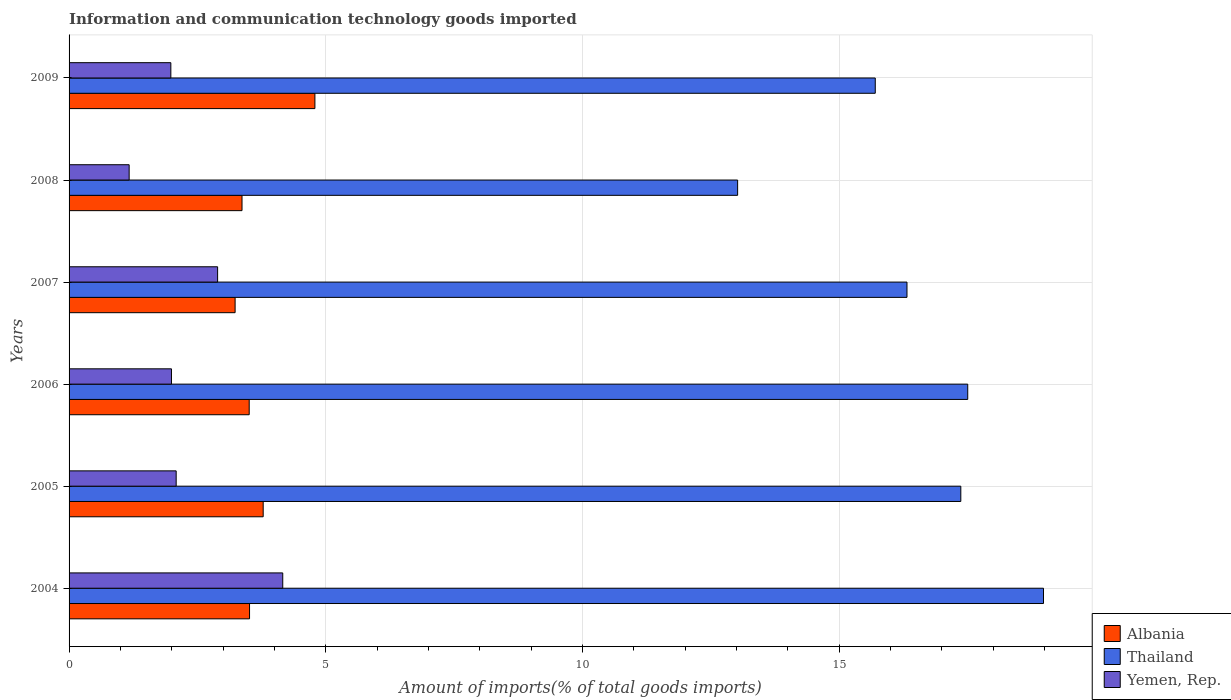How many groups of bars are there?
Provide a succinct answer. 6. Are the number of bars on each tick of the Y-axis equal?
Provide a short and direct response. Yes. How many bars are there on the 5th tick from the top?
Offer a very short reply. 3. How many bars are there on the 5th tick from the bottom?
Your answer should be compact. 3. What is the amount of goods imported in Albania in 2004?
Keep it short and to the point. 3.52. Across all years, what is the maximum amount of goods imported in Albania?
Ensure brevity in your answer.  4.79. Across all years, what is the minimum amount of goods imported in Thailand?
Provide a short and direct response. 13.02. In which year was the amount of goods imported in Yemen, Rep. minimum?
Your answer should be compact. 2008. What is the total amount of goods imported in Thailand in the graph?
Keep it short and to the point. 98.91. What is the difference between the amount of goods imported in Albania in 2004 and that in 2008?
Make the answer very short. 0.15. What is the difference between the amount of goods imported in Thailand in 2009 and the amount of goods imported in Yemen, Rep. in 2007?
Keep it short and to the point. 12.81. What is the average amount of goods imported in Yemen, Rep. per year?
Your response must be concise. 2.38. In the year 2007, what is the difference between the amount of goods imported in Albania and amount of goods imported in Thailand?
Your answer should be very brief. -13.09. In how many years, is the amount of goods imported in Thailand greater than 18 %?
Keep it short and to the point. 1. What is the ratio of the amount of goods imported in Albania in 2008 to that in 2009?
Give a very brief answer. 0.7. What is the difference between the highest and the second highest amount of goods imported in Thailand?
Offer a very short reply. 1.48. What is the difference between the highest and the lowest amount of goods imported in Thailand?
Offer a very short reply. 5.96. In how many years, is the amount of goods imported in Thailand greater than the average amount of goods imported in Thailand taken over all years?
Offer a terse response. 3. Is the sum of the amount of goods imported in Yemen, Rep. in 2005 and 2009 greater than the maximum amount of goods imported in Thailand across all years?
Your answer should be very brief. No. What does the 1st bar from the top in 2007 represents?
Your answer should be very brief. Yemen, Rep. What does the 2nd bar from the bottom in 2004 represents?
Provide a short and direct response. Thailand. How many bars are there?
Give a very brief answer. 18. How many years are there in the graph?
Offer a very short reply. 6. Where does the legend appear in the graph?
Make the answer very short. Bottom right. How are the legend labels stacked?
Offer a very short reply. Vertical. What is the title of the graph?
Give a very brief answer. Information and communication technology goods imported. Does "Caribbean small states" appear as one of the legend labels in the graph?
Offer a terse response. No. What is the label or title of the X-axis?
Keep it short and to the point. Amount of imports(% of total goods imports). What is the label or title of the Y-axis?
Your answer should be very brief. Years. What is the Amount of imports(% of total goods imports) of Albania in 2004?
Make the answer very short. 3.52. What is the Amount of imports(% of total goods imports) of Thailand in 2004?
Offer a very short reply. 18.98. What is the Amount of imports(% of total goods imports) in Yemen, Rep. in 2004?
Your response must be concise. 4.16. What is the Amount of imports(% of total goods imports) in Albania in 2005?
Offer a terse response. 3.78. What is the Amount of imports(% of total goods imports) of Thailand in 2005?
Offer a very short reply. 17.37. What is the Amount of imports(% of total goods imports) of Yemen, Rep. in 2005?
Ensure brevity in your answer.  2.09. What is the Amount of imports(% of total goods imports) in Albania in 2006?
Ensure brevity in your answer.  3.51. What is the Amount of imports(% of total goods imports) in Thailand in 2006?
Give a very brief answer. 17.51. What is the Amount of imports(% of total goods imports) of Yemen, Rep. in 2006?
Your answer should be very brief. 1.99. What is the Amount of imports(% of total goods imports) in Albania in 2007?
Your response must be concise. 3.23. What is the Amount of imports(% of total goods imports) of Thailand in 2007?
Offer a terse response. 16.32. What is the Amount of imports(% of total goods imports) in Yemen, Rep. in 2007?
Give a very brief answer. 2.89. What is the Amount of imports(% of total goods imports) of Albania in 2008?
Ensure brevity in your answer.  3.37. What is the Amount of imports(% of total goods imports) in Thailand in 2008?
Keep it short and to the point. 13.02. What is the Amount of imports(% of total goods imports) of Yemen, Rep. in 2008?
Your answer should be very brief. 1.17. What is the Amount of imports(% of total goods imports) in Albania in 2009?
Provide a succinct answer. 4.79. What is the Amount of imports(% of total goods imports) of Thailand in 2009?
Offer a very short reply. 15.7. What is the Amount of imports(% of total goods imports) of Yemen, Rep. in 2009?
Offer a very short reply. 1.98. Across all years, what is the maximum Amount of imports(% of total goods imports) in Albania?
Your answer should be compact. 4.79. Across all years, what is the maximum Amount of imports(% of total goods imports) in Thailand?
Ensure brevity in your answer.  18.98. Across all years, what is the maximum Amount of imports(% of total goods imports) in Yemen, Rep.?
Make the answer very short. 4.16. Across all years, what is the minimum Amount of imports(% of total goods imports) in Albania?
Offer a terse response. 3.23. Across all years, what is the minimum Amount of imports(% of total goods imports) of Thailand?
Ensure brevity in your answer.  13.02. Across all years, what is the minimum Amount of imports(% of total goods imports) in Yemen, Rep.?
Make the answer very short. 1.17. What is the total Amount of imports(% of total goods imports) of Albania in the graph?
Make the answer very short. 22.2. What is the total Amount of imports(% of total goods imports) of Thailand in the graph?
Your response must be concise. 98.91. What is the total Amount of imports(% of total goods imports) in Yemen, Rep. in the graph?
Offer a very short reply. 14.29. What is the difference between the Amount of imports(% of total goods imports) of Albania in 2004 and that in 2005?
Ensure brevity in your answer.  -0.27. What is the difference between the Amount of imports(% of total goods imports) in Thailand in 2004 and that in 2005?
Ensure brevity in your answer.  1.61. What is the difference between the Amount of imports(% of total goods imports) in Yemen, Rep. in 2004 and that in 2005?
Give a very brief answer. 2.08. What is the difference between the Amount of imports(% of total goods imports) in Albania in 2004 and that in 2006?
Ensure brevity in your answer.  0.01. What is the difference between the Amount of imports(% of total goods imports) of Thailand in 2004 and that in 2006?
Provide a short and direct response. 1.48. What is the difference between the Amount of imports(% of total goods imports) in Yemen, Rep. in 2004 and that in 2006?
Your answer should be very brief. 2.17. What is the difference between the Amount of imports(% of total goods imports) in Albania in 2004 and that in 2007?
Make the answer very short. 0.28. What is the difference between the Amount of imports(% of total goods imports) in Thailand in 2004 and that in 2007?
Ensure brevity in your answer.  2.66. What is the difference between the Amount of imports(% of total goods imports) in Yemen, Rep. in 2004 and that in 2007?
Provide a short and direct response. 1.27. What is the difference between the Amount of imports(% of total goods imports) in Albania in 2004 and that in 2008?
Provide a short and direct response. 0.15. What is the difference between the Amount of imports(% of total goods imports) of Thailand in 2004 and that in 2008?
Your answer should be very brief. 5.96. What is the difference between the Amount of imports(% of total goods imports) of Yemen, Rep. in 2004 and that in 2008?
Provide a short and direct response. 2.99. What is the difference between the Amount of imports(% of total goods imports) of Albania in 2004 and that in 2009?
Ensure brevity in your answer.  -1.27. What is the difference between the Amount of imports(% of total goods imports) in Thailand in 2004 and that in 2009?
Your answer should be very brief. 3.28. What is the difference between the Amount of imports(% of total goods imports) of Yemen, Rep. in 2004 and that in 2009?
Your answer should be compact. 2.18. What is the difference between the Amount of imports(% of total goods imports) of Albania in 2005 and that in 2006?
Offer a very short reply. 0.27. What is the difference between the Amount of imports(% of total goods imports) of Thailand in 2005 and that in 2006?
Offer a very short reply. -0.13. What is the difference between the Amount of imports(% of total goods imports) in Yemen, Rep. in 2005 and that in 2006?
Provide a succinct answer. 0.09. What is the difference between the Amount of imports(% of total goods imports) in Albania in 2005 and that in 2007?
Ensure brevity in your answer.  0.55. What is the difference between the Amount of imports(% of total goods imports) in Thailand in 2005 and that in 2007?
Provide a short and direct response. 1.05. What is the difference between the Amount of imports(% of total goods imports) in Yemen, Rep. in 2005 and that in 2007?
Ensure brevity in your answer.  -0.81. What is the difference between the Amount of imports(% of total goods imports) of Albania in 2005 and that in 2008?
Provide a succinct answer. 0.41. What is the difference between the Amount of imports(% of total goods imports) in Thailand in 2005 and that in 2008?
Give a very brief answer. 4.35. What is the difference between the Amount of imports(% of total goods imports) in Yemen, Rep. in 2005 and that in 2008?
Your response must be concise. 0.92. What is the difference between the Amount of imports(% of total goods imports) in Albania in 2005 and that in 2009?
Give a very brief answer. -1.01. What is the difference between the Amount of imports(% of total goods imports) in Thailand in 2005 and that in 2009?
Make the answer very short. 1.67. What is the difference between the Amount of imports(% of total goods imports) in Yemen, Rep. in 2005 and that in 2009?
Your answer should be compact. 0.1. What is the difference between the Amount of imports(% of total goods imports) in Albania in 2006 and that in 2007?
Keep it short and to the point. 0.27. What is the difference between the Amount of imports(% of total goods imports) of Thailand in 2006 and that in 2007?
Your answer should be compact. 1.18. What is the difference between the Amount of imports(% of total goods imports) of Yemen, Rep. in 2006 and that in 2007?
Keep it short and to the point. -0.9. What is the difference between the Amount of imports(% of total goods imports) of Albania in 2006 and that in 2008?
Provide a succinct answer. 0.14. What is the difference between the Amount of imports(% of total goods imports) of Thailand in 2006 and that in 2008?
Ensure brevity in your answer.  4.48. What is the difference between the Amount of imports(% of total goods imports) of Yemen, Rep. in 2006 and that in 2008?
Offer a terse response. 0.82. What is the difference between the Amount of imports(% of total goods imports) in Albania in 2006 and that in 2009?
Provide a short and direct response. -1.28. What is the difference between the Amount of imports(% of total goods imports) of Thailand in 2006 and that in 2009?
Provide a short and direct response. 1.8. What is the difference between the Amount of imports(% of total goods imports) in Yemen, Rep. in 2006 and that in 2009?
Give a very brief answer. 0.01. What is the difference between the Amount of imports(% of total goods imports) in Albania in 2007 and that in 2008?
Your answer should be compact. -0.13. What is the difference between the Amount of imports(% of total goods imports) of Thailand in 2007 and that in 2008?
Keep it short and to the point. 3.3. What is the difference between the Amount of imports(% of total goods imports) of Yemen, Rep. in 2007 and that in 2008?
Give a very brief answer. 1.72. What is the difference between the Amount of imports(% of total goods imports) in Albania in 2007 and that in 2009?
Offer a terse response. -1.55. What is the difference between the Amount of imports(% of total goods imports) in Thailand in 2007 and that in 2009?
Provide a succinct answer. 0.62. What is the difference between the Amount of imports(% of total goods imports) in Yemen, Rep. in 2007 and that in 2009?
Give a very brief answer. 0.91. What is the difference between the Amount of imports(% of total goods imports) in Albania in 2008 and that in 2009?
Your response must be concise. -1.42. What is the difference between the Amount of imports(% of total goods imports) of Thailand in 2008 and that in 2009?
Your answer should be very brief. -2.68. What is the difference between the Amount of imports(% of total goods imports) in Yemen, Rep. in 2008 and that in 2009?
Make the answer very short. -0.81. What is the difference between the Amount of imports(% of total goods imports) of Albania in 2004 and the Amount of imports(% of total goods imports) of Thailand in 2005?
Offer a very short reply. -13.86. What is the difference between the Amount of imports(% of total goods imports) in Albania in 2004 and the Amount of imports(% of total goods imports) in Yemen, Rep. in 2005?
Make the answer very short. 1.43. What is the difference between the Amount of imports(% of total goods imports) of Thailand in 2004 and the Amount of imports(% of total goods imports) of Yemen, Rep. in 2005?
Your response must be concise. 16.9. What is the difference between the Amount of imports(% of total goods imports) of Albania in 2004 and the Amount of imports(% of total goods imports) of Thailand in 2006?
Your answer should be very brief. -13.99. What is the difference between the Amount of imports(% of total goods imports) of Albania in 2004 and the Amount of imports(% of total goods imports) of Yemen, Rep. in 2006?
Provide a succinct answer. 1.52. What is the difference between the Amount of imports(% of total goods imports) of Thailand in 2004 and the Amount of imports(% of total goods imports) of Yemen, Rep. in 2006?
Keep it short and to the point. 16.99. What is the difference between the Amount of imports(% of total goods imports) in Albania in 2004 and the Amount of imports(% of total goods imports) in Thailand in 2007?
Your response must be concise. -12.81. What is the difference between the Amount of imports(% of total goods imports) of Albania in 2004 and the Amount of imports(% of total goods imports) of Yemen, Rep. in 2007?
Give a very brief answer. 0.62. What is the difference between the Amount of imports(% of total goods imports) of Thailand in 2004 and the Amount of imports(% of total goods imports) of Yemen, Rep. in 2007?
Provide a succinct answer. 16.09. What is the difference between the Amount of imports(% of total goods imports) of Albania in 2004 and the Amount of imports(% of total goods imports) of Thailand in 2008?
Give a very brief answer. -9.51. What is the difference between the Amount of imports(% of total goods imports) of Albania in 2004 and the Amount of imports(% of total goods imports) of Yemen, Rep. in 2008?
Provide a succinct answer. 2.35. What is the difference between the Amount of imports(% of total goods imports) of Thailand in 2004 and the Amount of imports(% of total goods imports) of Yemen, Rep. in 2008?
Make the answer very short. 17.81. What is the difference between the Amount of imports(% of total goods imports) in Albania in 2004 and the Amount of imports(% of total goods imports) in Thailand in 2009?
Ensure brevity in your answer.  -12.19. What is the difference between the Amount of imports(% of total goods imports) in Albania in 2004 and the Amount of imports(% of total goods imports) in Yemen, Rep. in 2009?
Provide a succinct answer. 1.53. What is the difference between the Amount of imports(% of total goods imports) of Thailand in 2004 and the Amount of imports(% of total goods imports) of Yemen, Rep. in 2009?
Ensure brevity in your answer.  17. What is the difference between the Amount of imports(% of total goods imports) of Albania in 2005 and the Amount of imports(% of total goods imports) of Thailand in 2006?
Ensure brevity in your answer.  -13.72. What is the difference between the Amount of imports(% of total goods imports) of Albania in 2005 and the Amount of imports(% of total goods imports) of Yemen, Rep. in 2006?
Offer a terse response. 1.79. What is the difference between the Amount of imports(% of total goods imports) in Thailand in 2005 and the Amount of imports(% of total goods imports) in Yemen, Rep. in 2006?
Your answer should be compact. 15.38. What is the difference between the Amount of imports(% of total goods imports) of Albania in 2005 and the Amount of imports(% of total goods imports) of Thailand in 2007?
Your answer should be very brief. -12.54. What is the difference between the Amount of imports(% of total goods imports) in Albania in 2005 and the Amount of imports(% of total goods imports) in Yemen, Rep. in 2007?
Offer a terse response. 0.89. What is the difference between the Amount of imports(% of total goods imports) of Thailand in 2005 and the Amount of imports(% of total goods imports) of Yemen, Rep. in 2007?
Make the answer very short. 14.48. What is the difference between the Amount of imports(% of total goods imports) in Albania in 2005 and the Amount of imports(% of total goods imports) in Thailand in 2008?
Your answer should be compact. -9.24. What is the difference between the Amount of imports(% of total goods imports) of Albania in 2005 and the Amount of imports(% of total goods imports) of Yemen, Rep. in 2008?
Keep it short and to the point. 2.61. What is the difference between the Amount of imports(% of total goods imports) of Thailand in 2005 and the Amount of imports(% of total goods imports) of Yemen, Rep. in 2008?
Your answer should be very brief. 16.2. What is the difference between the Amount of imports(% of total goods imports) of Albania in 2005 and the Amount of imports(% of total goods imports) of Thailand in 2009?
Your answer should be very brief. -11.92. What is the difference between the Amount of imports(% of total goods imports) of Albania in 2005 and the Amount of imports(% of total goods imports) of Yemen, Rep. in 2009?
Your response must be concise. 1.8. What is the difference between the Amount of imports(% of total goods imports) of Thailand in 2005 and the Amount of imports(% of total goods imports) of Yemen, Rep. in 2009?
Keep it short and to the point. 15.39. What is the difference between the Amount of imports(% of total goods imports) of Albania in 2006 and the Amount of imports(% of total goods imports) of Thailand in 2007?
Offer a very short reply. -12.81. What is the difference between the Amount of imports(% of total goods imports) in Albania in 2006 and the Amount of imports(% of total goods imports) in Yemen, Rep. in 2007?
Offer a terse response. 0.62. What is the difference between the Amount of imports(% of total goods imports) of Thailand in 2006 and the Amount of imports(% of total goods imports) of Yemen, Rep. in 2007?
Your answer should be very brief. 14.61. What is the difference between the Amount of imports(% of total goods imports) in Albania in 2006 and the Amount of imports(% of total goods imports) in Thailand in 2008?
Ensure brevity in your answer.  -9.51. What is the difference between the Amount of imports(% of total goods imports) in Albania in 2006 and the Amount of imports(% of total goods imports) in Yemen, Rep. in 2008?
Ensure brevity in your answer.  2.34. What is the difference between the Amount of imports(% of total goods imports) of Thailand in 2006 and the Amount of imports(% of total goods imports) of Yemen, Rep. in 2008?
Give a very brief answer. 16.34. What is the difference between the Amount of imports(% of total goods imports) of Albania in 2006 and the Amount of imports(% of total goods imports) of Thailand in 2009?
Provide a short and direct response. -12.2. What is the difference between the Amount of imports(% of total goods imports) in Albania in 2006 and the Amount of imports(% of total goods imports) in Yemen, Rep. in 2009?
Give a very brief answer. 1.53. What is the difference between the Amount of imports(% of total goods imports) in Thailand in 2006 and the Amount of imports(% of total goods imports) in Yemen, Rep. in 2009?
Offer a very short reply. 15.52. What is the difference between the Amount of imports(% of total goods imports) of Albania in 2007 and the Amount of imports(% of total goods imports) of Thailand in 2008?
Give a very brief answer. -9.79. What is the difference between the Amount of imports(% of total goods imports) in Albania in 2007 and the Amount of imports(% of total goods imports) in Yemen, Rep. in 2008?
Ensure brevity in your answer.  2.06. What is the difference between the Amount of imports(% of total goods imports) in Thailand in 2007 and the Amount of imports(% of total goods imports) in Yemen, Rep. in 2008?
Offer a very short reply. 15.15. What is the difference between the Amount of imports(% of total goods imports) of Albania in 2007 and the Amount of imports(% of total goods imports) of Thailand in 2009?
Your response must be concise. -12.47. What is the difference between the Amount of imports(% of total goods imports) in Albania in 2007 and the Amount of imports(% of total goods imports) in Yemen, Rep. in 2009?
Ensure brevity in your answer.  1.25. What is the difference between the Amount of imports(% of total goods imports) of Thailand in 2007 and the Amount of imports(% of total goods imports) of Yemen, Rep. in 2009?
Your response must be concise. 14.34. What is the difference between the Amount of imports(% of total goods imports) in Albania in 2008 and the Amount of imports(% of total goods imports) in Thailand in 2009?
Make the answer very short. -12.34. What is the difference between the Amount of imports(% of total goods imports) in Albania in 2008 and the Amount of imports(% of total goods imports) in Yemen, Rep. in 2009?
Make the answer very short. 1.39. What is the difference between the Amount of imports(% of total goods imports) in Thailand in 2008 and the Amount of imports(% of total goods imports) in Yemen, Rep. in 2009?
Your answer should be compact. 11.04. What is the average Amount of imports(% of total goods imports) of Albania per year?
Your answer should be very brief. 3.7. What is the average Amount of imports(% of total goods imports) in Thailand per year?
Your response must be concise. 16.48. What is the average Amount of imports(% of total goods imports) of Yemen, Rep. per year?
Offer a terse response. 2.38. In the year 2004, what is the difference between the Amount of imports(% of total goods imports) of Albania and Amount of imports(% of total goods imports) of Thailand?
Keep it short and to the point. -15.47. In the year 2004, what is the difference between the Amount of imports(% of total goods imports) of Albania and Amount of imports(% of total goods imports) of Yemen, Rep.?
Your answer should be very brief. -0.65. In the year 2004, what is the difference between the Amount of imports(% of total goods imports) in Thailand and Amount of imports(% of total goods imports) in Yemen, Rep.?
Offer a terse response. 14.82. In the year 2005, what is the difference between the Amount of imports(% of total goods imports) in Albania and Amount of imports(% of total goods imports) in Thailand?
Offer a terse response. -13.59. In the year 2005, what is the difference between the Amount of imports(% of total goods imports) of Albania and Amount of imports(% of total goods imports) of Yemen, Rep.?
Make the answer very short. 1.7. In the year 2005, what is the difference between the Amount of imports(% of total goods imports) of Thailand and Amount of imports(% of total goods imports) of Yemen, Rep.?
Your answer should be very brief. 15.28. In the year 2006, what is the difference between the Amount of imports(% of total goods imports) in Albania and Amount of imports(% of total goods imports) in Thailand?
Offer a very short reply. -14. In the year 2006, what is the difference between the Amount of imports(% of total goods imports) in Albania and Amount of imports(% of total goods imports) in Yemen, Rep.?
Your answer should be compact. 1.51. In the year 2006, what is the difference between the Amount of imports(% of total goods imports) in Thailand and Amount of imports(% of total goods imports) in Yemen, Rep.?
Ensure brevity in your answer.  15.51. In the year 2007, what is the difference between the Amount of imports(% of total goods imports) of Albania and Amount of imports(% of total goods imports) of Thailand?
Offer a very short reply. -13.09. In the year 2007, what is the difference between the Amount of imports(% of total goods imports) in Albania and Amount of imports(% of total goods imports) in Yemen, Rep.?
Ensure brevity in your answer.  0.34. In the year 2007, what is the difference between the Amount of imports(% of total goods imports) in Thailand and Amount of imports(% of total goods imports) in Yemen, Rep.?
Offer a very short reply. 13.43. In the year 2008, what is the difference between the Amount of imports(% of total goods imports) in Albania and Amount of imports(% of total goods imports) in Thailand?
Make the answer very short. -9.65. In the year 2008, what is the difference between the Amount of imports(% of total goods imports) of Albania and Amount of imports(% of total goods imports) of Yemen, Rep.?
Ensure brevity in your answer.  2.2. In the year 2008, what is the difference between the Amount of imports(% of total goods imports) in Thailand and Amount of imports(% of total goods imports) in Yemen, Rep.?
Your answer should be compact. 11.85. In the year 2009, what is the difference between the Amount of imports(% of total goods imports) of Albania and Amount of imports(% of total goods imports) of Thailand?
Make the answer very short. -10.92. In the year 2009, what is the difference between the Amount of imports(% of total goods imports) of Albania and Amount of imports(% of total goods imports) of Yemen, Rep.?
Give a very brief answer. 2.81. In the year 2009, what is the difference between the Amount of imports(% of total goods imports) of Thailand and Amount of imports(% of total goods imports) of Yemen, Rep.?
Keep it short and to the point. 13.72. What is the ratio of the Amount of imports(% of total goods imports) of Albania in 2004 to that in 2005?
Provide a short and direct response. 0.93. What is the ratio of the Amount of imports(% of total goods imports) in Thailand in 2004 to that in 2005?
Your response must be concise. 1.09. What is the ratio of the Amount of imports(% of total goods imports) in Yemen, Rep. in 2004 to that in 2005?
Provide a short and direct response. 2. What is the ratio of the Amount of imports(% of total goods imports) of Thailand in 2004 to that in 2006?
Offer a terse response. 1.08. What is the ratio of the Amount of imports(% of total goods imports) in Yemen, Rep. in 2004 to that in 2006?
Your response must be concise. 2.09. What is the ratio of the Amount of imports(% of total goods imports) in Albania in 2004 to that in 2007?
Make the answer very short. 1.09. What is the ratio of the Amount of imports(% of total goods imports) of Thailand in 2004 to that in 2007?
Provide a succinct answer. 1.16. What is the ratio of the Amount of imports(% of total goods imports) in Yemen, Rep. in 2004 to that in 2007?
Your response must be concise. 1.44. What is the ratio of the Amount of imports(% of total goods imports) of Albania in 2004 to that in 2008?
Your answer should be very brief. 1.04. What is the ratio of the Amount of imports(% of total goods imports) of Thailand in 2004 to that in 2008?
Make the answer very short. 1.46. What is the ratio of the Amount of imports(% of total goods imports) of Yemen, Rep. in 2004 to that in 2008?
Your response must be concise. 3.56. What is the ratio of the Amount of imports(% of total goods imports) in Albania in 2004 to that in 2009?
Make the answer very short. 0.73. What is the ratio of the Amount of imports(% of total goods imports) of Thailand in 2004 to that in 2009?
Provide a short and direct response. 1.21. What is the ratio of the Amount of imports(% of total goods imports) in Yemen, Rep. in 2004 to that in 2009?
Your answer should be compact. 2.1. What is the ratio of the Amount of imports(% of total goods imports) in Albania in 2005 to that in 2006?
Your answer should be compact. 1.08. What is the ratio of the Amount of imports(% of total goods imports) of Thailand in 2005 to that in 2006?
Make the answer very short. 0.99. What is the ratio of the Amount of imports(% of total goods imports) in Yemen, Rep. in 2005 to that in 2006?
Your response must be concise. 1.05. What is the ratio of the Amount of imports(% of total goods imports) of Albania in 2005 to that in 2007?
Provide a succinct answer. 1.17. What is the ratio of the Amount of imports(% of total goods imports) of Thailand in 2005 to that in 2007?
Provide a succinct answer. 1.06. What is the ratio of the Amount of imports(% of total goods imports) of Yemen, Rep. in 2005 to that in 2007?
Give a very brief answer. 0.72. What is the ratio of the Amount of imports(% of total goods imports) of Albania in 2005 to that in 2008?
Your answer should be very brief. 1.12. What is the ratio of the Amount of imports(% of total goods imports) of Thailand in 2005 to that in 2008?
Provide a short and direct response. 1.33. What is the ratio of the Amount of imports(% of total goods imports) in Yemen, Rep. in 2005 to that in 2008?
Your answer should be compact. 1.78. What is the ratio of the Amount of imports(% of total goods imports) of Albania in 2005 to that in 2009?
Provide a succinct answer. 0.79. What is the ratio of the Amount of imports(% of total goods imports) in Thailand in 2005 to that in 2009?
Offer a very short reply. 1.11. What is the ratio of the Amount of imports(% of total goods imports) in Yemen, Rep. in 2005 to that in 2009?
Your answer should be compact. 1.05. What is the ratio of the Amount of imports(% of total goods imports) in Albania in 2006 to that in 2007?
Your answer should be compact. 1.08. What is the ratio of the Amount of imports(% of total goods imports) of Thailand in 2006 to that in 2007?
Make the answer very short. 1.07. What is the ratio of the Amount of imports(% of total goods imports) of Yemen, Rep. in 2006 to that in 2007?
Offer a very short reply. 0.69. What is the ratio of the Amount of imports(% of total goods imports) in Albania in 2006 to that in 2008?
Make the answer very short. 1.04. What is the ratio of the Amount of imports(% of total goods imports) in Thailand in 2006 to that in 2008?
Your response must be concise. 1.34. What is the ratio of the Amount of imports(% of total goods imports) in Yemen, Rep. in 2006 to that in 2008?
Provide a succinct answer. 1.7. What is the ratio of the Amount of imports(% of total goods imports) in Albania in 2006 to that in 2009?
Provide a short and direct response. 0.73. What is the ratio of the Amount of imports(% of total goods imports) in Thailand in 2006 to that in 2009?
Offer a terse response. 1.11. What is the ratio of the Amount of imports(% of total goods imports) of Albania in 2007 to that in 2008?
Your answer should be very brief. 0.96. What is the ratio of the Amount of imports(% of total goods imports) in Thailand in 2007 to that in 2008?
Make the answer very short. 1.25. What is the ratio of the Amount of imports(% of total goods imports) of Yemen, Rep. in 2007 to that in 2008?
Keep it short and to the point. 2.47. What is the ratio of the Amount of imports(% of total goods imports) of Albania in 2007 to that in 2009?
Your response must be concise. 0.68. What is the ratio of the Amount of imports(% of total goods imports) in Thailand in 2007 to that in 2009?
Your answer should be compact. 1.04. What is the ratio of the Amount of imports(% of total goods imports) in Yemen, Rep. in 2007 to that in 2009?
Ensure brevity in your answer.  1.46. What is the ratio of the Amount of imports(% of total goods imports) in Albania in 2008 to that in 2009?
Your answer should be compact. 0.7. What is the ratio of the Amount of imports(% of total goods imports) in Thailand in 2008 to that in 2009?
Provide a succinct answer. 0.83. What is the ratio of the Amount of imports(% of total goods imports) of Yemen, Rep. in 2008 to that in 2009?
Your answer should be compact. 0.59. What is the difference between the highest and the second highest Amount of imports(% of total goods imports) in Albania?
Make the answer very short. 1.01. What is the difference between the highest and the second highest Amount of imports(% of total goods imports) of Thailand?
Provide a succinct answer. 1.48. What is the difference between the highest and the second highest Amount of imports(% of total goods imports) in Yemen, Rep.?
Ensure brevity in your answer.  1.27. What is the difference between the highest and the lowest Amount of imports(% of total goods imports) in Albania?
Offer a terse response. 1.55. What is the difference between the highest and the lowest Amount of imports(% of total goods imports) in Thailand?
Your answer should be compact. 5.96. What is the difference between the highest and the lowest Amount of imports(% of total goods imports) of Yemen, Rep.?
Your response must be concise. 2.99. 